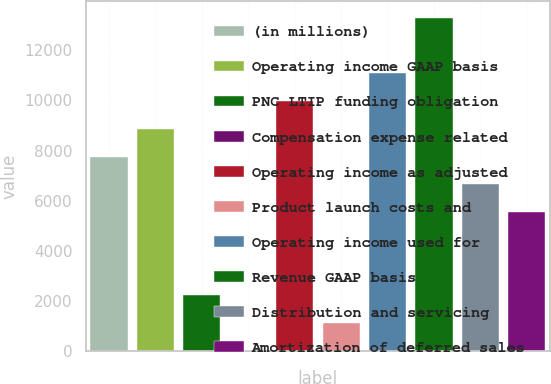<chart> <loc_0><loc_0><loc_500><loc_500><bar_chart><fcel>(in millions)<fcel>Operating income GAAP basis<fcel>PNC LTIP funding obligation<fcel>Compensation expense related<fcel>Operating income as adjusted<fcel>Product launch costs and<fcel>Operating income used for<fcel>Revenue GAAP basis<fcel>Distribution and servicing<fcel>Amortization of deferred sales<nl><fcel>7758.8<fcel>8866.2<fcel>2221.8<fcel>7<fcel>9973.6<fcel>1114.4<fcel>11081<fcel>13295.8<fcel>6651.4<fcel>5544<nl></chart> 